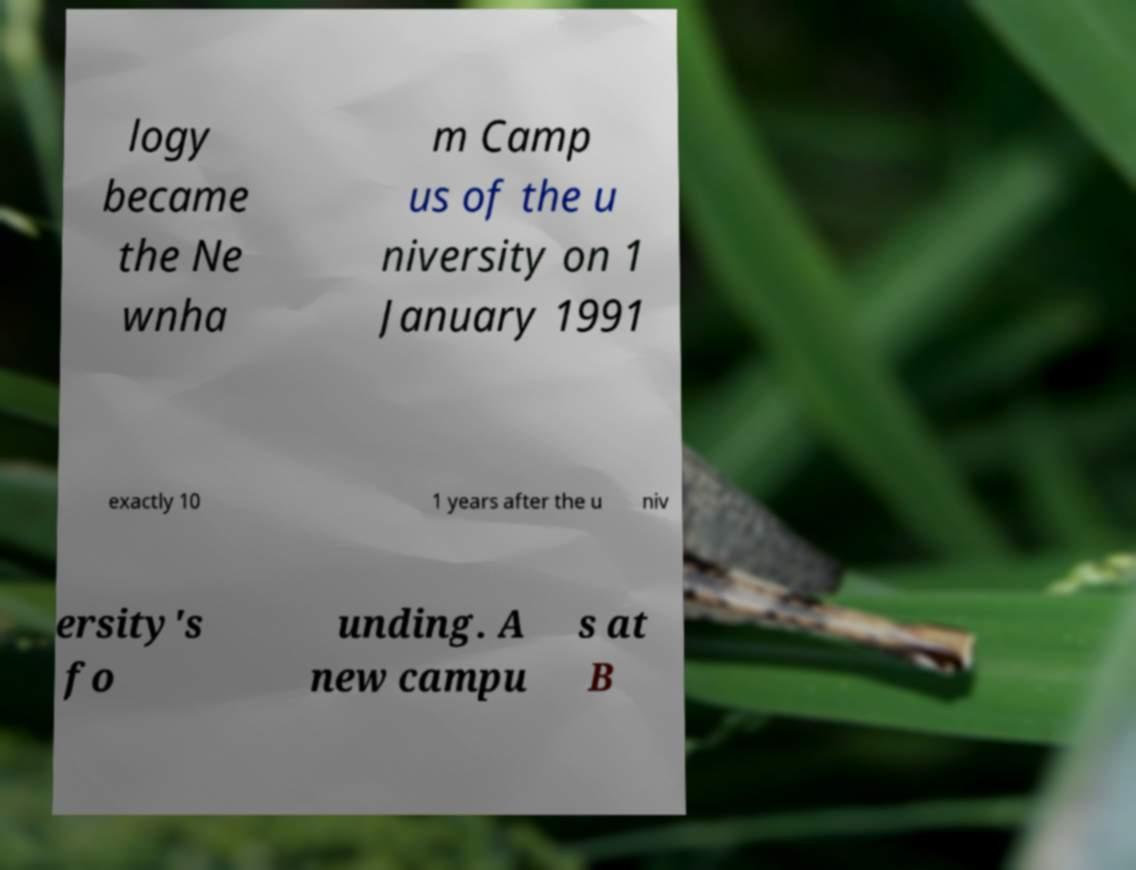I need the written content from this picture converted into text. Can you do that? logy became the Ne wnha m Camp us of the u niversity on 1 January 1991 exactly 10 1 years after the u niv ersity's fo unding. A new campu s at B 